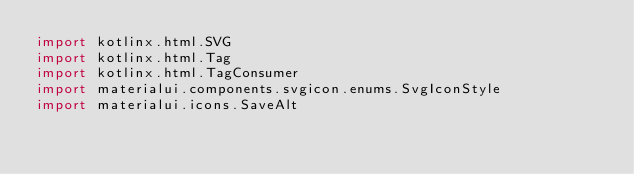Convert code to text. <code><loc_0><loc_0><loc_500><loc_500><_Kotlin_>import kotlinx.html.SVG
import kotlinx.html.Tag
import kotlinx.html.TagConsumer
import materialui.components.svgicon.enums.SvgIconStyle
import materialui.icons.SaveAlt</code> 